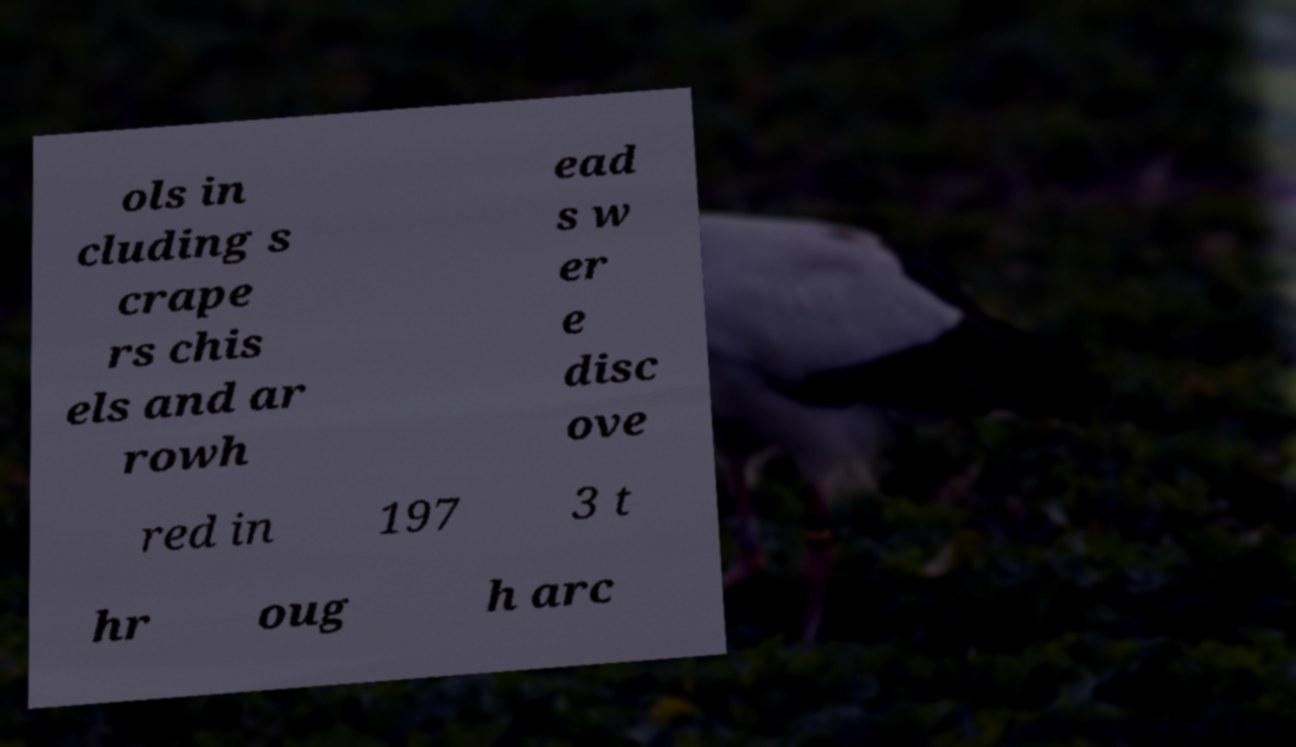I need the written content from this picture converted into text. Can you do that? ols in cluding s crape rs chis els and ar rowh ead s w er e disc ove red in 197 3 t hr oug h arc 